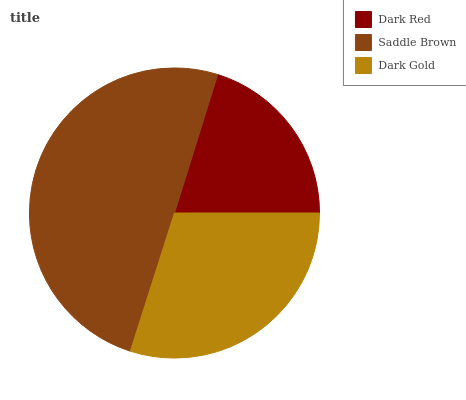Is Dark Red the minimum?
Answer yes or no. Yes. Is Saddle Brown the maximum?
Answer yes or no. Yes. Is Dark Gold the minimum?
Answer yes or no. No. Is Dark Gold the maximum?
Answer yes or no. No. Is Saddle Brown greater than Dark Gold?
Answer yes or no. Yes. Is Dark Gold less than Saddle Brown?
Answer yes or no. Yes. Is Dark Gold greater than Saddle Brown?
Answer yes or no. No. Is Saddle Brown less than Dark Gold?
Answer yes or no. No. Is Dark Gold the high median?
Answer yes or no. Yes. Is Dark Gold the low median?
Answer yes or no. Yes. Is Dark Red the high median?
Answer yes or no. No. Is Dark Red the low median?
Answer yes or no. No. 